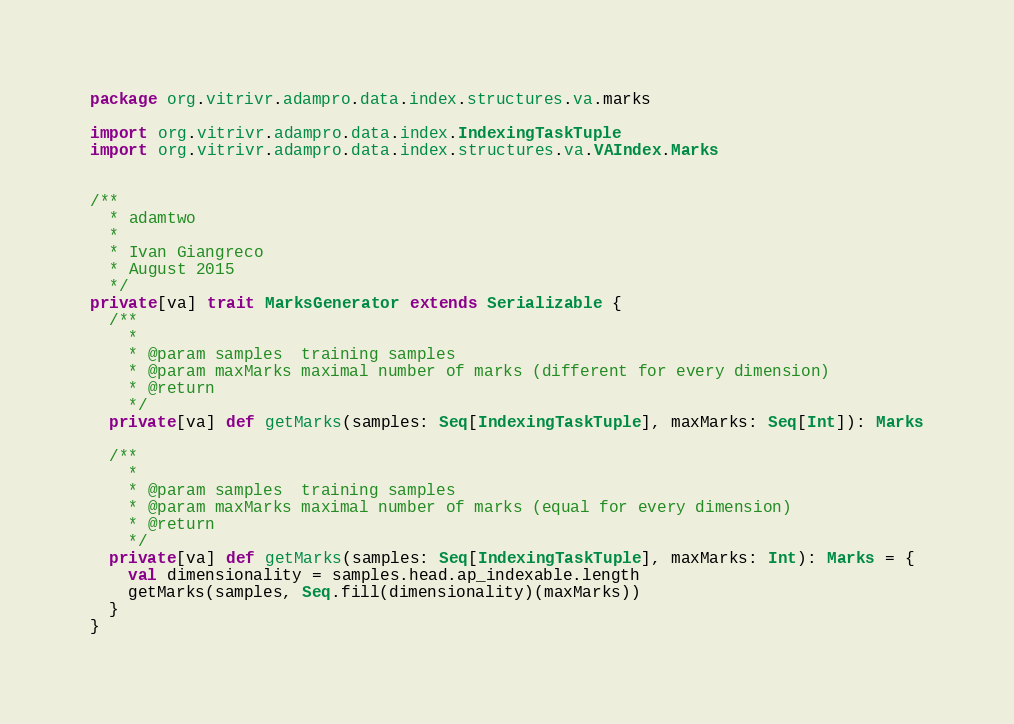Convert code to text. <code><loc_0><loc_0><loc_500><loc_500><_Scala_>package org.vitrivr.adampro.data.index.structures.va.marks

import org.vitrivr.adampro.data.index.IndexingTaskTuple
import org.vitrivr.adampro.data.index.structures.va.VAIndex.Marks


/**
  * adamtwo
  *
  * Ivan Giangreco
  * August 2015
  */
private[va] trait MarksGenerator extends Serializable {
  /**
    *
    * @param samples  training samples
    * @param maxMarks maximal number of marks (different for every dimension)
    * @return
    */
  private[va] def getMarks(samples: Seq[IndexingTaskTuple], maxMarks: Seq[Int]): Marks

  /**
    *
    * @param samples  training samples
    * @param maxMarks maximal number of marks (equal for every dimension)
    * @return
    */
  private[va] def getMarks(samples: Seq[IndexingTaskTuple], maxMarks: Int): Marks = {
    val dimensionality = samples.head.ap_indexable.length
    getMarks(samples, Seq.fill(dimensionality)(maxMarks))
  }
}
</code> 